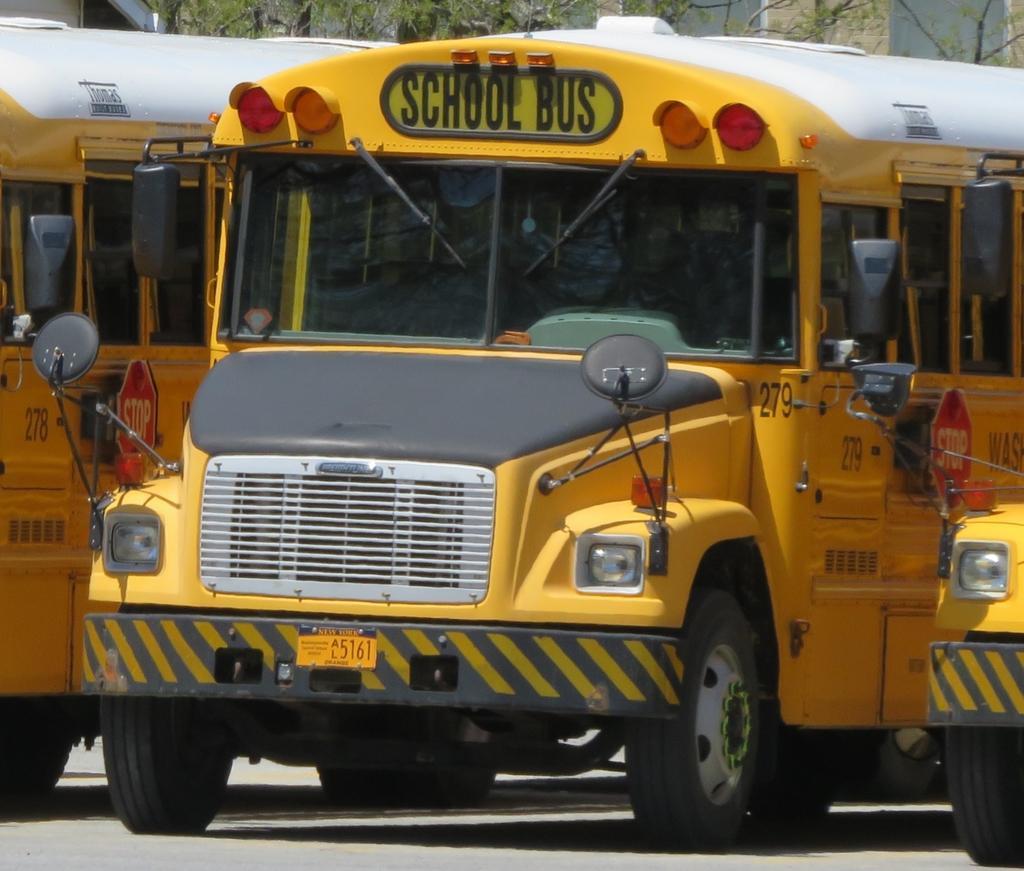Could you give a brief overview of what you see in this image? In this picture we can see the vehicles. At the top of the image we can see the trees, wall and windows. At the bottom of the image we can see the road. 